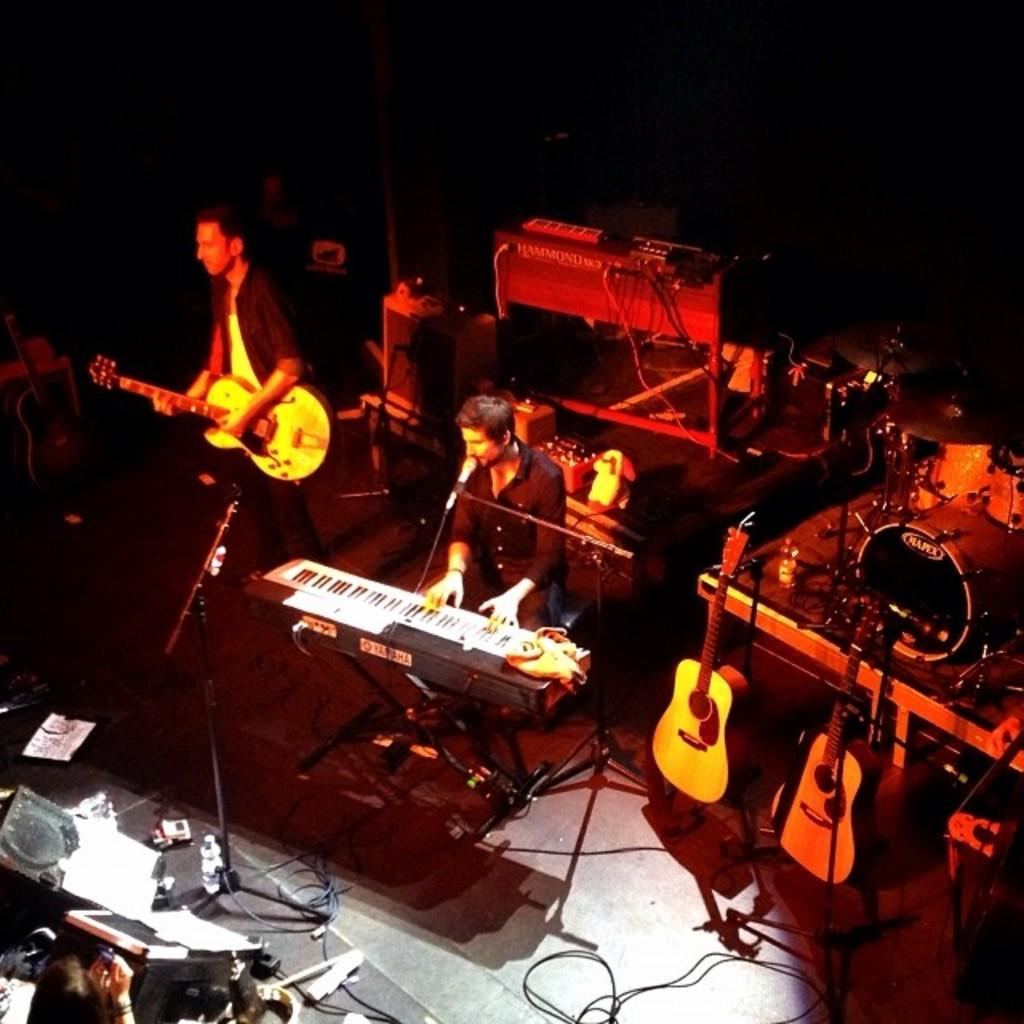How many people are in the image? There are two persons in the image. What are the two persons doing in the image? The two persons are standing and playing musical instruments. What type of quiver can be seen on the person playing the violin in the image? There is no quiver present in the image; the two persons are playing musical instruments, but no quivers are visible. 